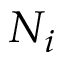<formula> <loc_0><loc_0><loc_500><loc_500>N _ { i }</formula> 